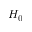<formula> <loc_0><loc_0><loc_500><loc_500>H _ { 0 }</formula> 